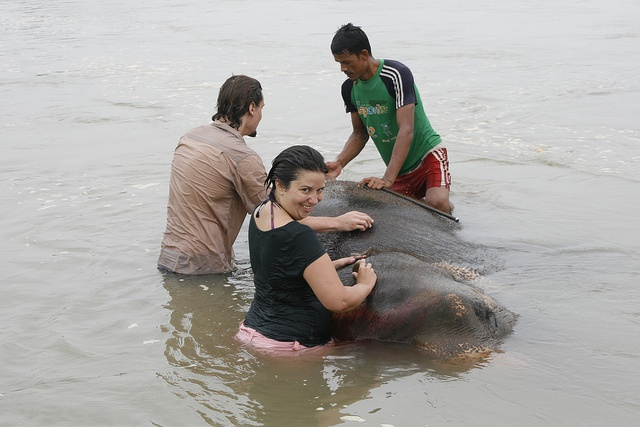Describe the objects in this image and their specific colors. I can see elephant in lightgray, gray, black, and darkgray tones, people in lightgray, black, gray, and tan tones, people in lightgray, darkgray, and gray tones, and people in lightgray, black, darkgreen, maroon, and gray tones in this image. 